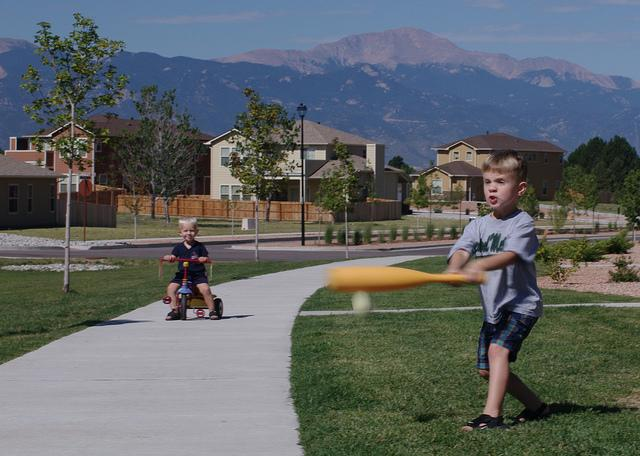What is the child travelling on? Please explain your reasoning. tricycle. The vehicle in question is clearly visible and has three wheels. 